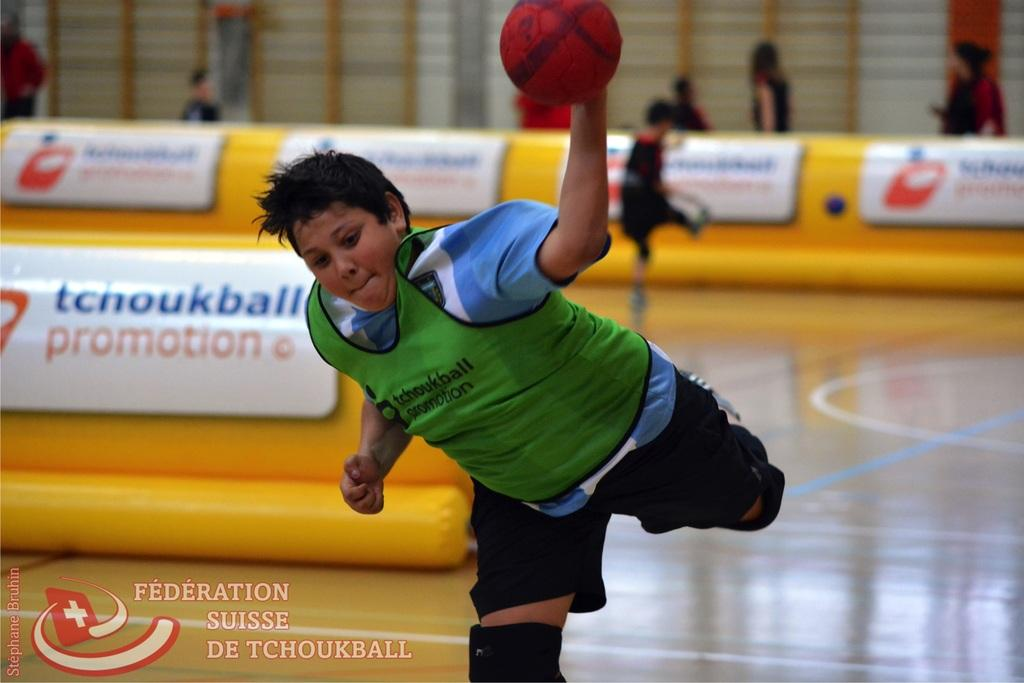Who is the main subject in the image? There is a boy in the image. What is the boy holding in his hand? The boy is holding a ball in his left hand. What is the boy doing with the ball? The boy is throwing the ball. What other object can be seen in the image? There is a yellow color air ball in the image. Are there any other people visible in the image? Yes, there are people visible in the image. What type of cheese is the boy eating in the image? There is no cheese present in the image; the boy is holding and throwing a ball. Can you tell me how many ants are crawling on the boy's back in the image? There are no ants visible on the boy's back in the image. 